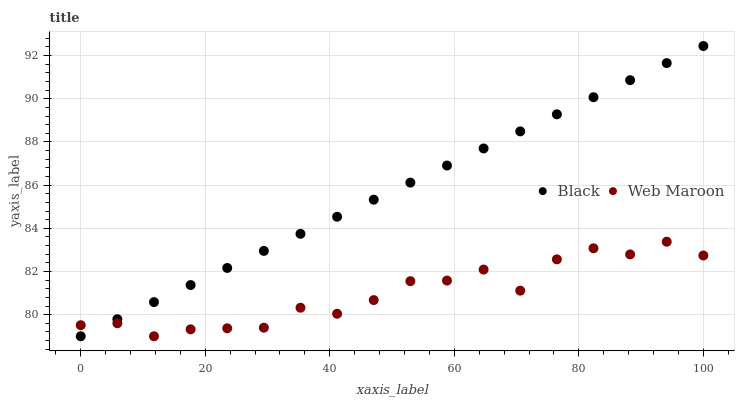Does Web Maroon have the minimum area under the curve?
Answer yes or no. Yes. Does Black have the maximum area under the curve?
Answer yes or no. Yes. Does Black have the minimum area under the curve?
Answer yes or no. No. Is Black the smoothest?
Answer yes or no. Yes. Is Web Maroon the roughest?
Answer yes or no. Yes. Is Black the roughest?
Answer yes or no. No. Does Web Maroon have the lowest value?
Answer yes or no. Yes. Does Black have the highest value?
Answer yes or no. Yes. Does Black intersect Web Maroon?
Answer yes or no. Yes. Is Black less than Web Maroon?
Answer yes or no. No. Is Black greater than Web Maroon?
Answer yes or no. No. 